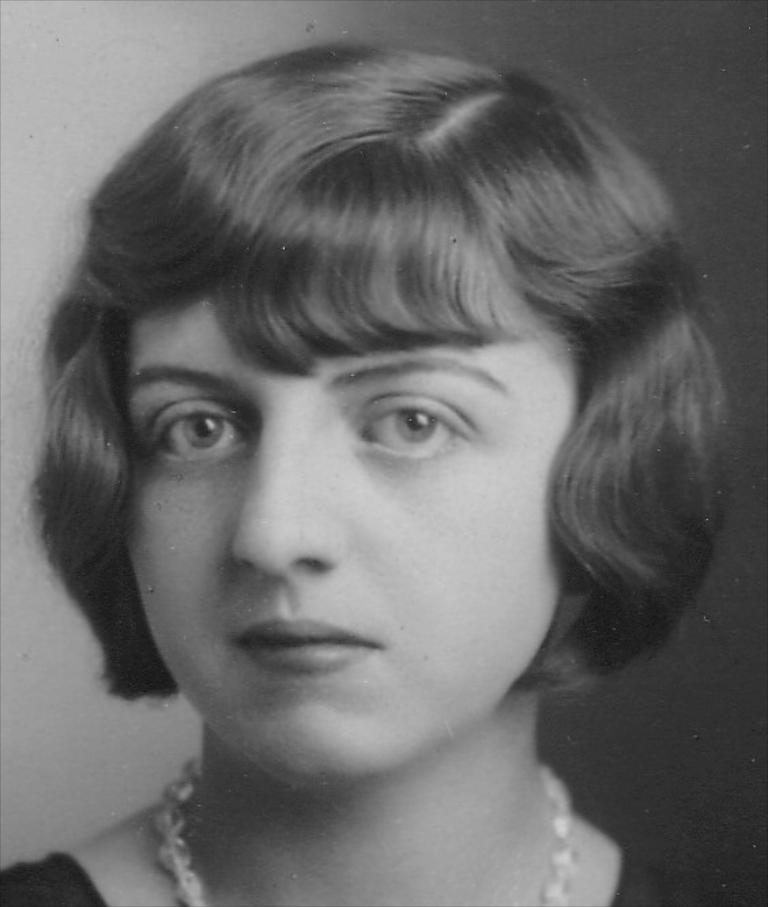Describe this image in one or two sentences. This is a black and white picture. We can see a woman. Behind the woman there is the blurred background. 